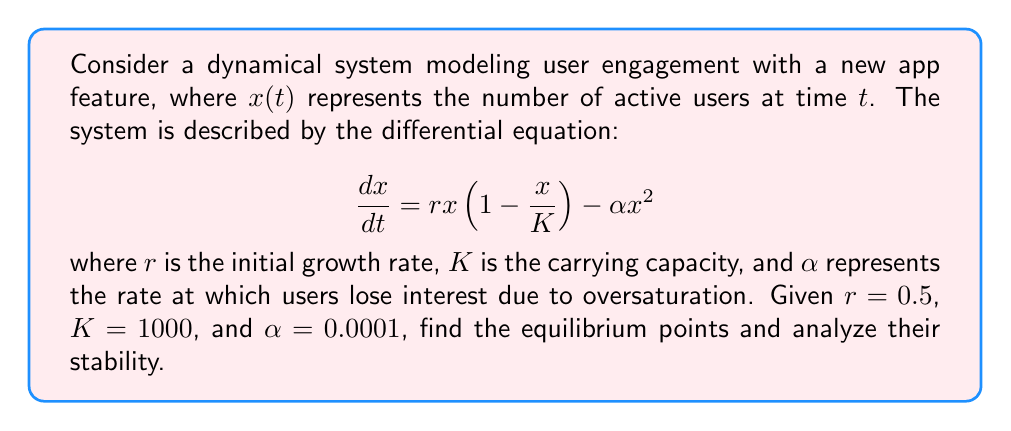Provide a solution to this math problem. 1. Find the equilibrium points by setting $\frac{dx}{dt} = 0$:
   $$0 = rx(1 - \frac{x}{K}) - \alpha x^2$$
   $$0 = 0.5x(1 - \frac{x}{1000}) - 0.0001x^2$$

2. Factor out $x$:
   $$x(0.5 - 0.0005x - 0.0001x) = 0$$
   $$x(0.5 - 0.0006x) = 0$$

3. Solve for $x$:
   $x = 0$ or $0.5 - 0.0006x = 0$
   $x = 0$ or $x = \frac{0.5}{0.0006} \approx 833.33$

4. Analyze stability by finding $\frac{df}{dx}$:
   $$\frac{df}{dx} = r(1 - \frac{2x}{K}) - 2\alpha x$$
   $$\frac{df}{dx} = 0.5(1 - \frac{2x}{1000}) - 0.0002x$$

5. Evaluate $\frac{df}{dx}$ at each equilibrium point:
   At $x = 0$: $\frac{df}{dx} = 0.5 > 0$ (unstable)
   At $x \approx 833.33$: $\frac{df}{dx} \approx -0.3333 < 0$ (stable)

6. Interpret results:
   The system has two equilibrium points: 0 and approximately 833.33 active users.
   The zero equilibrium is unstable, meaning any small number of users will grow.
   The non-zero equilibrium is stable, indicating the system will tend towards this number of active users over time.
Answer: Two equilibrium points: 0 (unstable) and 833.33 (stable) 